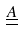Convert formula to latex. <formula><loc_0><loc_0><loc_500><loc_500>\underline { \underline { A } }</formula> 